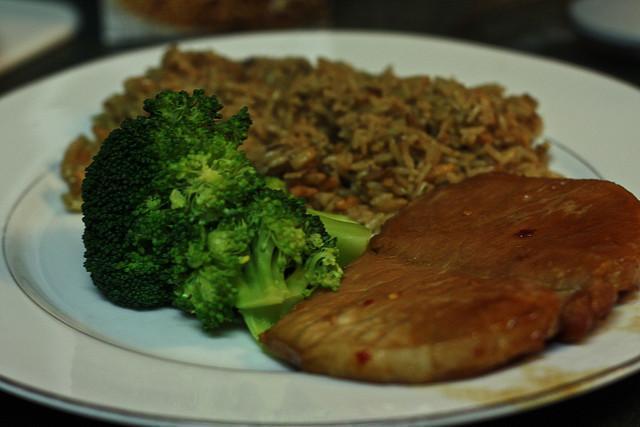How many different kinds of food are there?
Give a very brief answer. 3. 